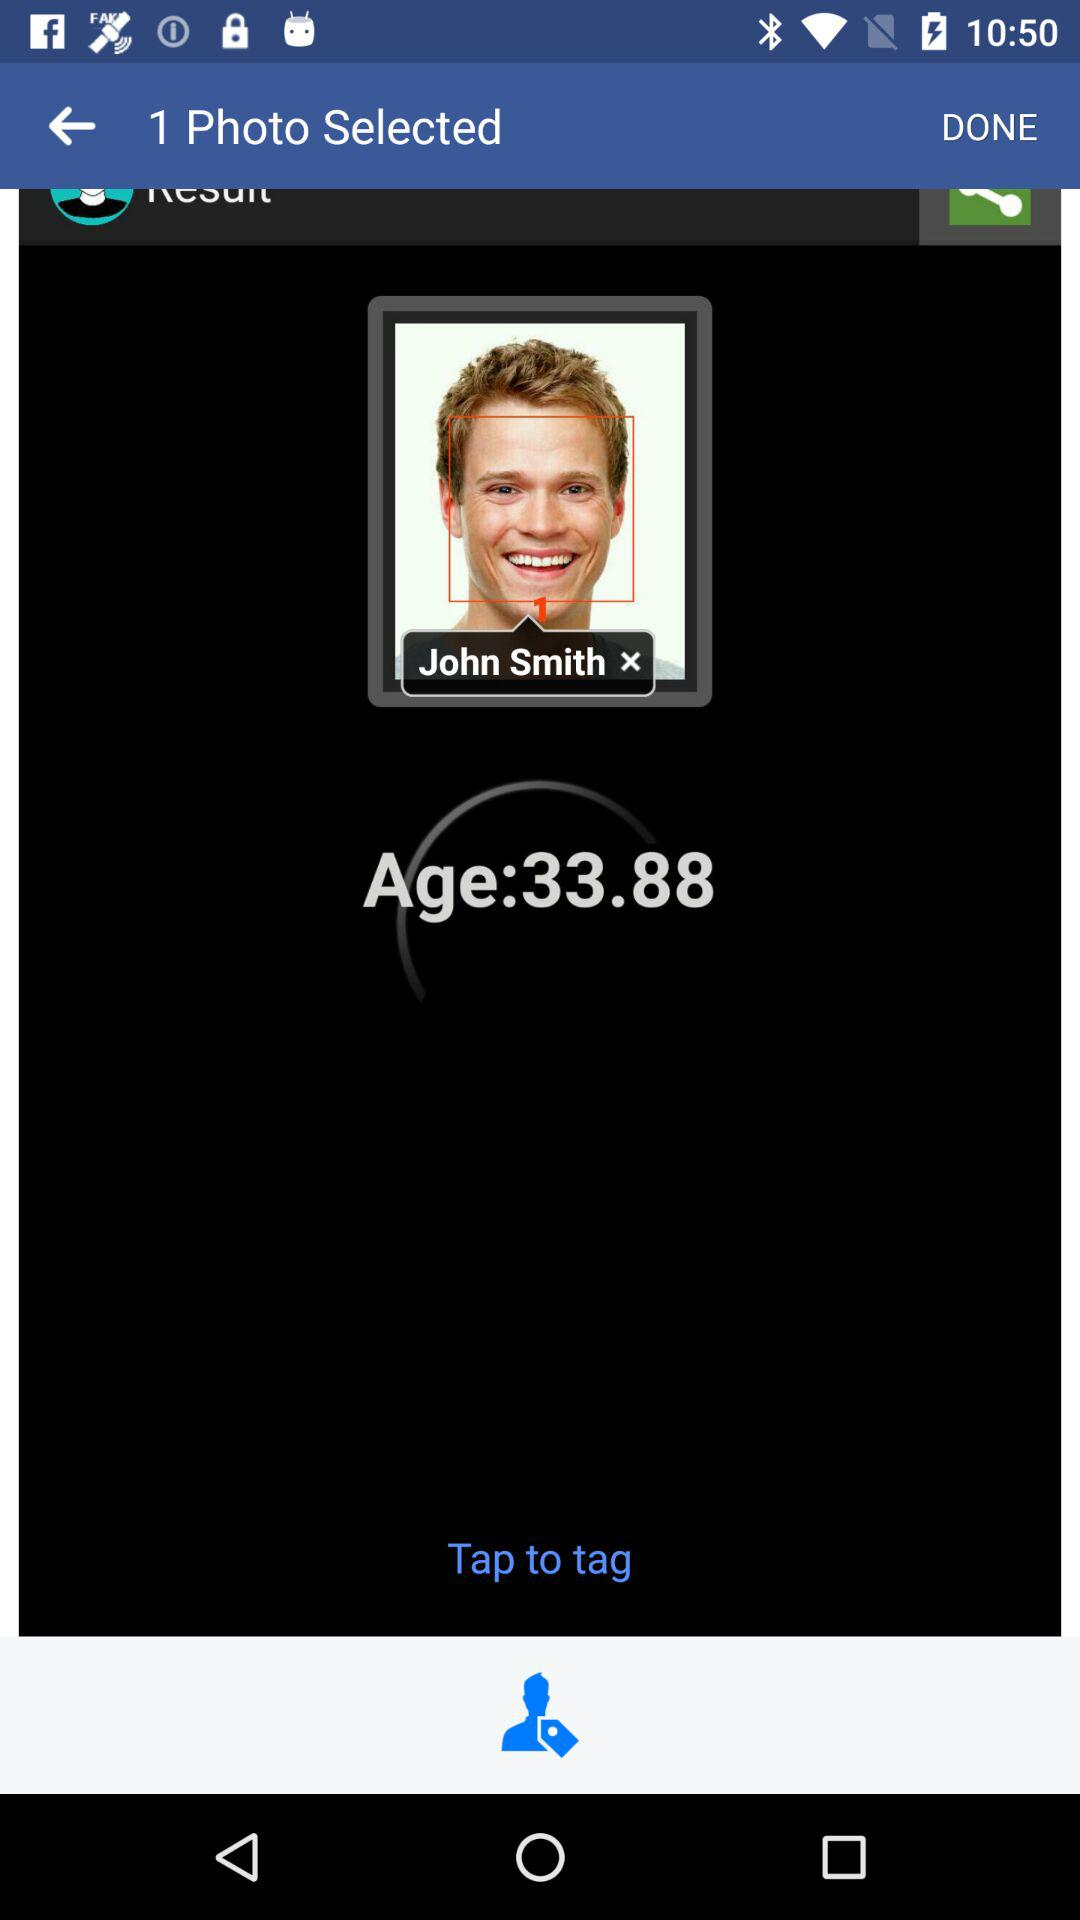How many photos are selected? There is 1 photo selected. 